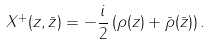Convert formula to latex. <formula><loc_0><loc_0><loc_500><loc_500>X ^ { + } ( z , \bar { z } ) = - \frac { i } { 2 } \left ( \rho ( z ) + \bar { \rho } ( \bar { z } ) \right ) .</formula> 